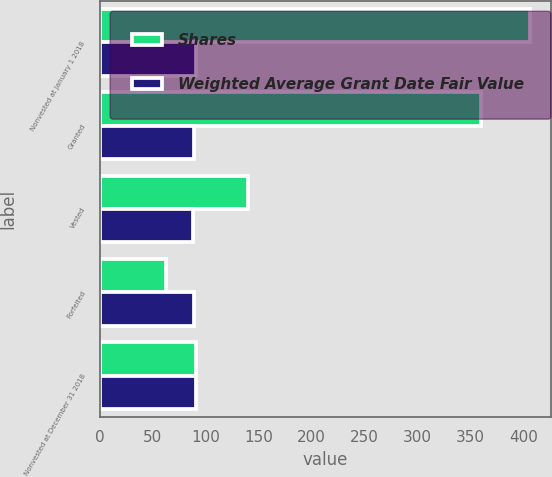<chart> <loc_0><loc_0><loc_500><loc_500><stacked_bar_chart><ecel><fcel>Nonvested at January 1 2018<fcel>Granted<fcel>Vested<fcel>Forfeited<fcel>Nonvested at December 31 2018<nl><fcel>Shares<fcel>406<fcel>360<fcel>140<fcel>63<fcel>91<nl><fcel>Weighted Average Grant Date Fair Value<fcel>91<fcel>89<fcel>88<fcel>89<fcel>91<nl></chart> 